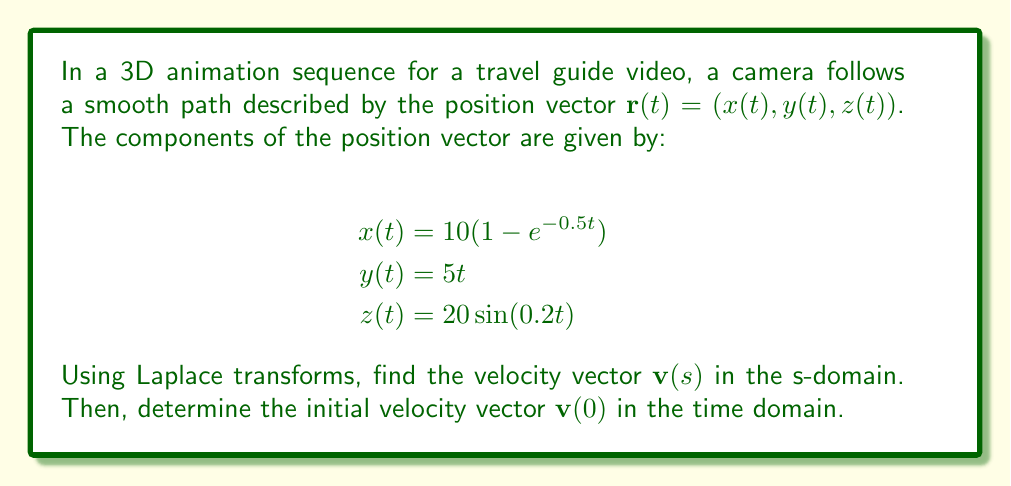Provide a solution to this math problem. To solve this problem, we'll follow these steps:

1) First, let's recall that the Laplace transform of a derivative is given by:
   $\mathcal{L}\{f'(t)\} = sF(s) - f(0)$

2) The velocity vector is the derivative of the position vector with respect to time. So, we need to find $\mathbf{v}(s) = \mathcal{L}\{\mathbf{r}'(t)\}$.

3) Let's find the Laplace transform of each component:

   For $x(t)$:
   $\mathcal{L}\{x(t)\} = \mathcal{L}\{10(1-e^{-0.5t})\} = \frac{10}{s} - \frac{5}{s+0.5}$
   $\mathcal{L}\{x'(t)\} = s\mathcal{L}\{x(t)\} - x(0) = 10 - \frac{5s}{s+0.5} - 0 = \frac{5}{s+0.5}$

   For $y(t)$:
   $\mathcal{L}\{y(t)\} = \mathcal{L}\{5t\} = \frac{5}{s^2}$
   $\mathcal{L}\{y'(t)\} = s\mathcal{L}\{y(t)\} - y(0) = \frac{5}{s} - 0 = \frac{5}{s}$

   For $z(t)$:
   $\mathcal{L}\{z(t)\} = \mathcal{L}\{20\sin(0.2t)\} = \frac{4}{s^2+0.04}$
   $\mathcal{L}\{z'(t)\} = s\mathcal{L}\{z(t)\} - z(0) = \frac{4s}{s^2+0.04} - 0 = \frac{4s}{s^2+0.04}$

4) Therefore, the velocity vector in the s-domain is:

   $$\mathbf{v}(s) = \left(\frac{5}{s+0.5}, \frac{5}{s}, \frac{4s}{s^2+0.04}\right)$$

5) To find the initial velocity vector $\mathbf{v}(0)$, we need to use the Final Value Theorem:
   $\lim_{t \to 0} f(t) = \lim_{s \to \infty} sF(s)$

   For $v_x(0)$: $\lim_{s \to \infty} s \cdot \frac{5}{s+0.5} = 5$
   For $v_y(0)$: $\lim_{s \to \infty} s \cdot \frac{5}{s} = 5$
   For $v_z(0)$: $\lim_{s \to \infty} s \cdot \frac{4s}{s^2+0.04} = 0$

Therefore, the initial velocity vector is $\mathbf{v}(0) = (5, 5, 0)$.
Answer: The velocity vector in the s-domain is:
$$\mathbf{v}(s) = \left(\frac{5}{s+0.5}, \frac{5}{s}, \frac{4s}{s^2+0.04}\right)$$

The initial velocity vector in the time domain is:
$$\mathbf{v}(0) = (5, 5, 0)$$ 